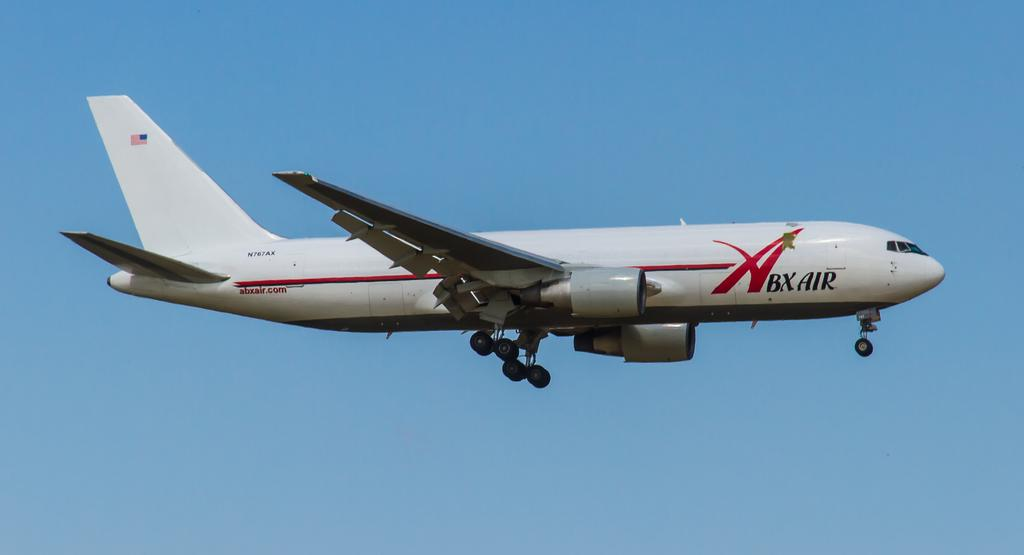What is the main subject of the picture? The main subject of the picture is an airplane. What can be seen in the background of the image? The sky is visible in the picture. What type of liquid is the farmer using to water the crops in the image? There is no farmer or crops present in the image; it features an airplane and the sky. What is the income of the person who took the picture of the airplane and sky? The income of the person who took the picture is not mentioned or visible in the image. 